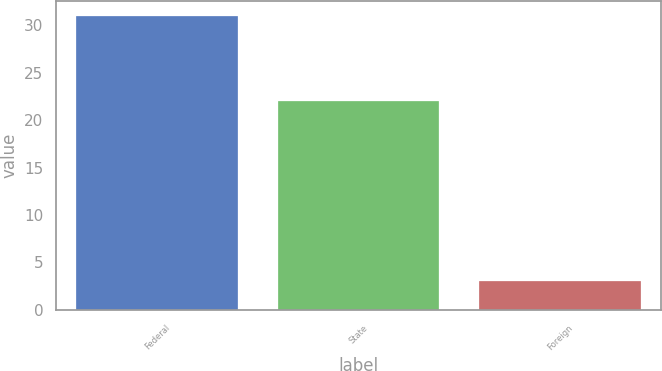Convert chart. <chart><loc_0><loc_0><loc_500><loc_500><bar_chart><fcel>Federal<fcel>State<fcel>Foreign<nl><fcel>31<fcel>22<fcel>3<nl></chart> 